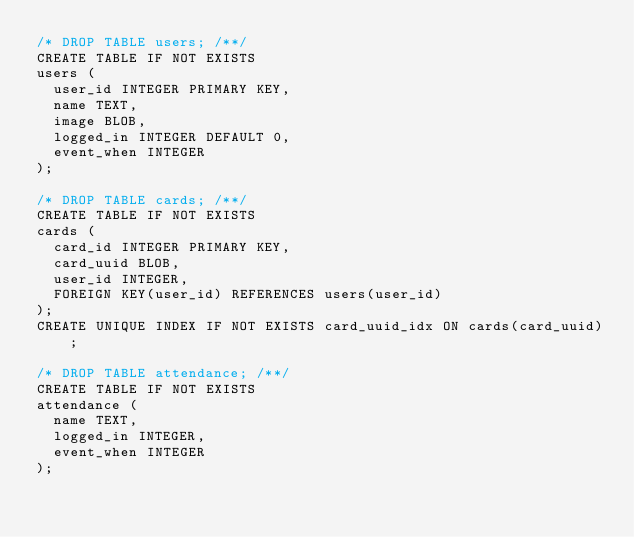<code> <loc_0><loc_0><loc_500><loc_500><_SQL_>/* DROP TABLE users; /**/
CREATE TABLE IF NOT EXISTS
users (
  user_id INTEGER PRIMARY KEY,
  name TEXT,
  image BLOB,
  logged_in INTEGER DEFAULT 0,
  event_when INTEGER
);

/* DROP TABLE cards; /**/
CREATE TABLE IF NOT EXISTS
cards (
  card_id INTEGER PRIMARY KEY,
  card_uuid BLOB,
  user_id INTEGER,
  FOREIGN KEY(user_id) REFERENCES users(user_id)
);
CREATE UNIQUE INDEX IF NOT EXISTS card_uuid_idx ON cards(card_uuid);

/* DROP TABLE attendance; /**/
CREATE TABLE IF NOT EXISTS
attendance (
  name TEXT,
  logged_in INTEGER,
  event_when INTEGER
);
</code> 